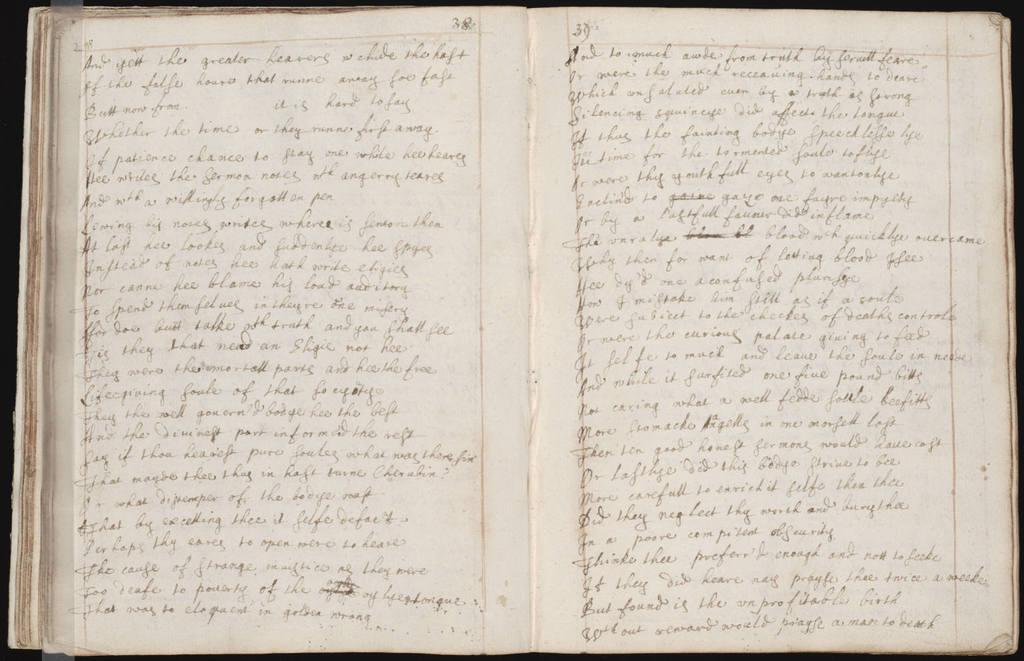What is depicted on the pages in the image? There are pages of a book in the image, and something is written on them. What is the color of the pages in the image? The color of the pages is white. What type of bait is used to catch fish in the image? There is no bait or fishing activity present in the image; it features pages of a book. How many trees are visible in the image? There are no trees visible in the image; it features pages of a book. 